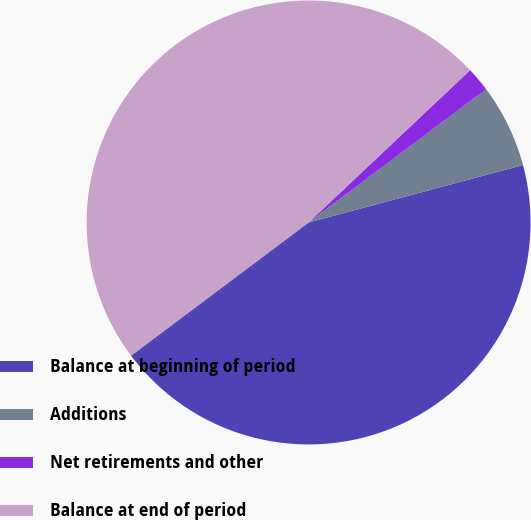Convert chart to OTSL. <chart><loc_0><loc_0><loc_500><loc_500><pie_chart><fcel>Balance at beginning of period<fcel>Additions<fcel>Net retirements and other<fcel>Balance at end of period<nl><fcel>43.92%<fcel>6.08%<fcel>1.79%<fcel>48.21%<nl></chart> 